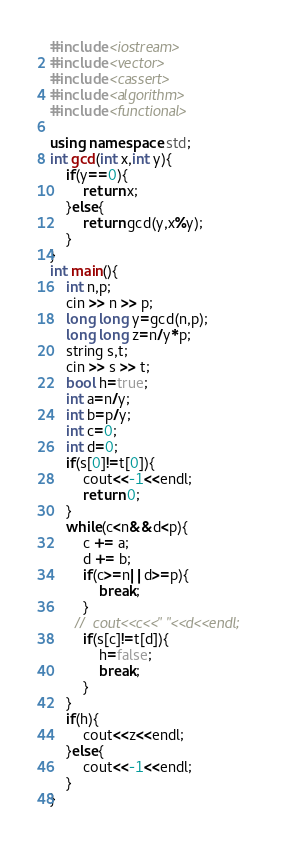Convert code to text. <code><loc_0><loc_0><loc_500><loc_500><_C++_>#include <iostream>
#include <vector>
#include <cassert>
#include <algorithm>
#include <functional>

using namespace std;
int gcd(int x,int y){
    if(y==0){
        return x;
    }else{
        return gcd(y,x%y);
    }
}
int main(){
    int n,p;
    cin >> n >> p;
    long long y=gcd(n,p);
    long long z=n/y*p;
    string s,t;
    cin >> s >> t;
    bool h=true;
    int a=n/y;
    int b=p/y;
    int c=0;
    int d=0;
    if(s[0]!=t[0]){
        cout<<-1<<endl;
        return 0;
    }
    while(c<n&&d<p){
        c += a;
        d += b;
        if(c>=n||d>=p){
            break;
        }
      //  cout<<c<<" "<<d<<endl;
        if(s[c]!=t[d]){
            h=false;
            break;
        }
    }
    if(h){
        cout<<z<<endl;
    }else{
        cout<<-1<<endl;
    }
}</code> 